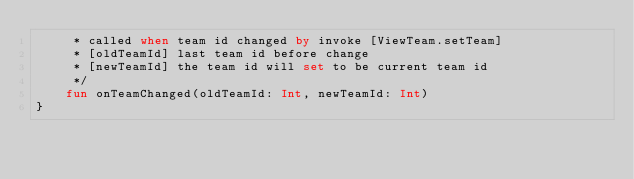<code> <loc_0><loc_0><loc_500><loc_500><_Kotlin_>     * called when team id changed by invoke [ViewTeam.setTeam]
     * [oldTeamId] last team id before change
     * [newTeamId] the team id will set to be current team id
     */
    fun onTeamChanged(oldTeamId: Int, newTeamId: Int)
}</code> 